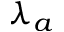Convert formula to latex. <formula><loc_0><loc_0><loc_500><loc_500>\lambda _ { a }</formula> 